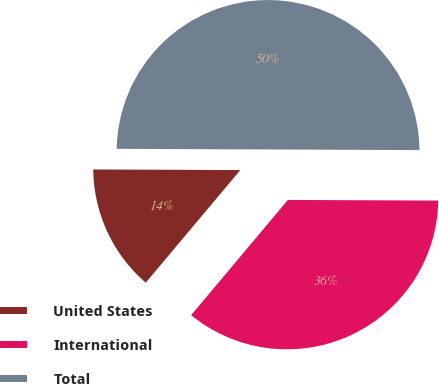<chart> <loc_0><loc_0><loc_500><loc_500><pie_chart><fcel>United States<fcel>International<fcel>Total<nl><fcel>13.95%<fcel>36.05%<fcel>50.0%<nl></chart> 